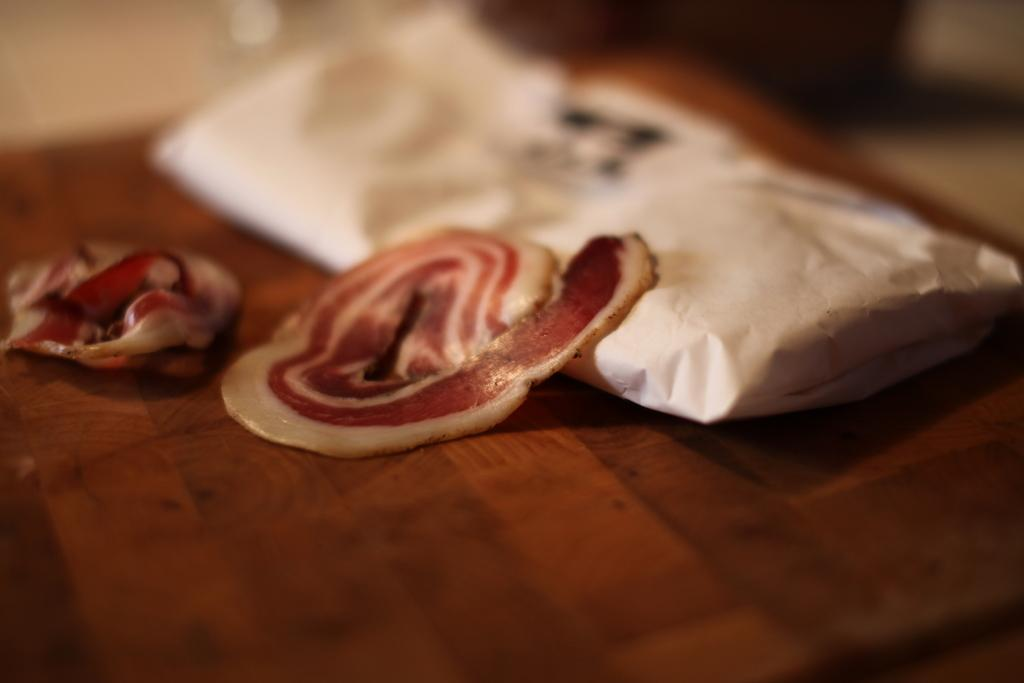What type of food can be seen in the image? There are meat slices in the image. What else is present in the image besides the meat slices? There is a white packet in the image. On what surface are the meat slices and white packet placed? The objects are placed on a wooden board. What flavor of discussion is taking place in the image? There is no discussion present in the image, as it features meat slices and a white packet on a wooden board. 